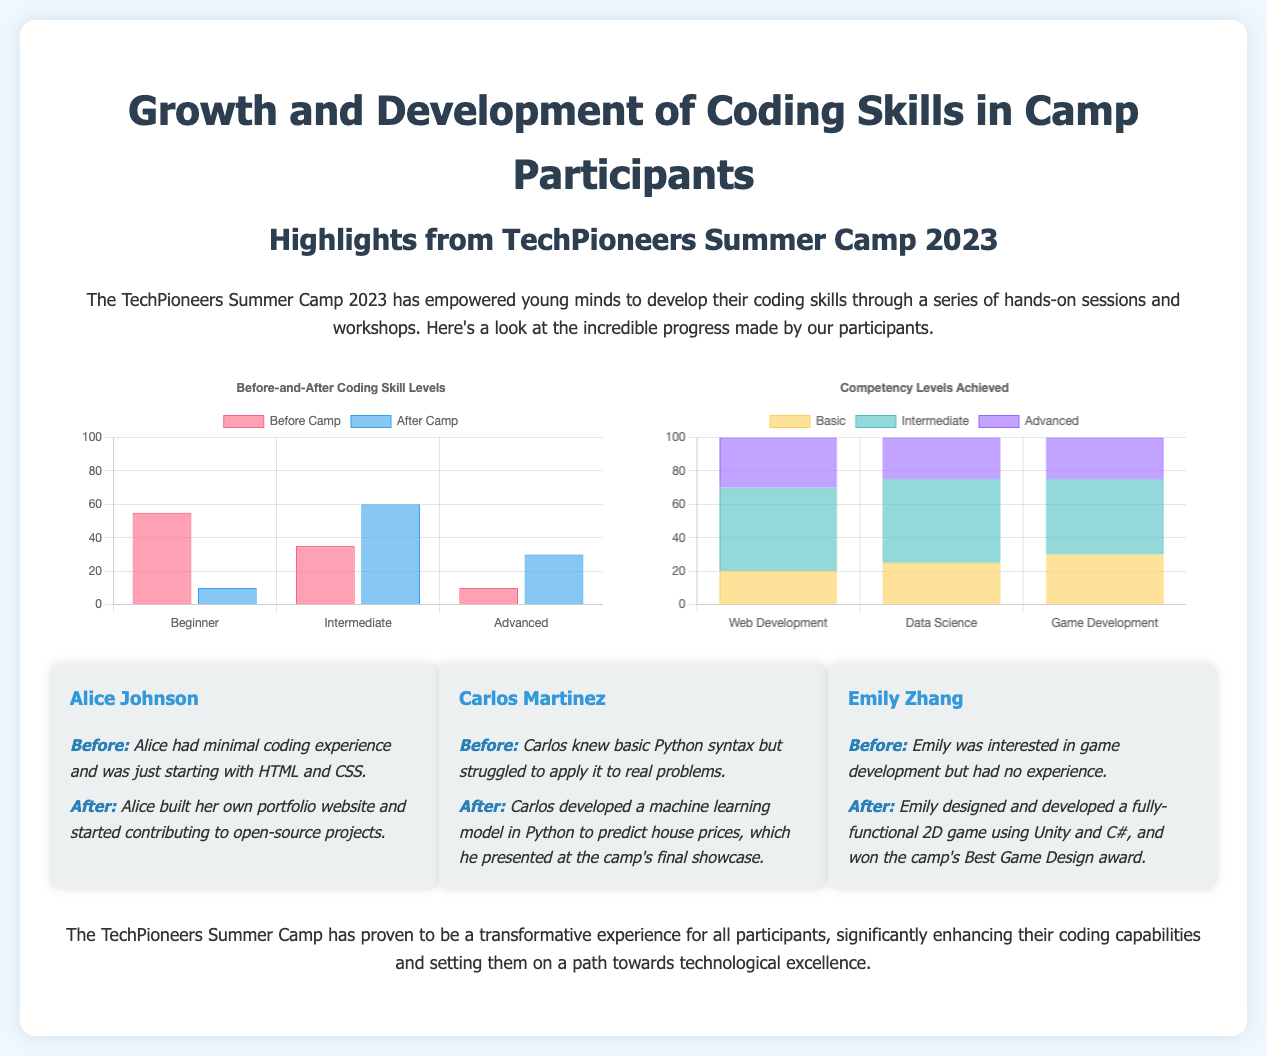What is the title of the document? The title states the main focus of the infographic, which is about the growth and development of coding skills in camp participants.
Answer: Growth and Development of Coding Skills in Camp Participants How many participants were at the Beginner level before the camp? The chart provides specific numbers showing the distribution of skill levels before the camp, which indicated 55 participants were at the Beginner level.
Answer: 55 What percentage of participants reached the Intermediate level after the camp? The chart illustrates that after the camp, there were 60 participants at the Intermediate level, thus indicating a high success rate in progressing to this level.
Answer: 60 Which success story mentions game development? The success stories section highlights different participants’ achievements, and game development is specifically noted in Emily Zhang's story.
Answer: Emily Zhang What was the competency level achieved by most participants in Web Development? The competency levels chart shows the achieved levels in various areas, specifically indicating that Web Development had the highest number at the Basic level.
Answer: Basic Who developed a machine learning model? The success stories detail individual accomplishments, stating that Carlos Martinez developed a machine learning model.
Answer: Carlos Martinez What is the total percentage of participants at the Advanced level before the camp? Referring to the chart, the number of participants at the Advanced level before the camp is given as 10, making the total percentage easily calculable from the overall number of 100.
Answer: 10 How many total coding sessions were offered? The document outlines the experiences of the camp participants, but does not explicitly mention the total number of coding sessions offered.
Answer: Not specified What type of chart is used to display Before-and-After skill levels? The document describes the methodology for showcasing the progress made, and it utilizes a bar chart to display Before-and-After skill levels.
Answer: Bar chart 